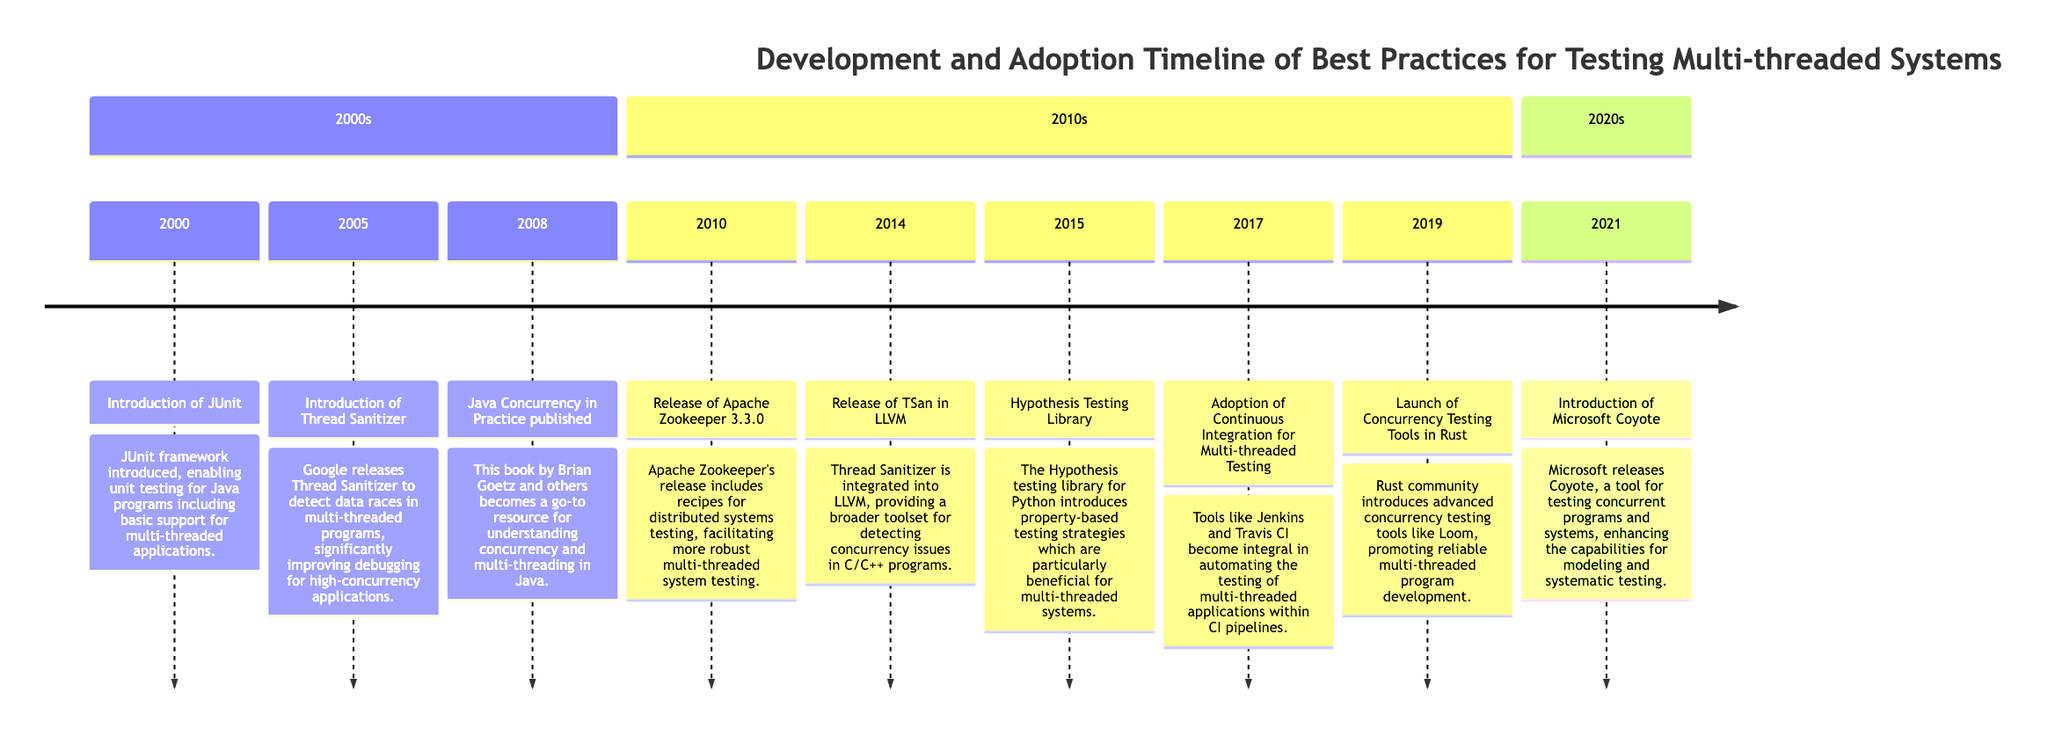What event was introduced in 2000? The timeline indicates that in 2000, the "Introduction of JUnit" was the event. This is explicitly stated in the diagram and marks a significant moment in the development of testing frameworks for multi-threaded systems.
Answer: Introduction of JUnit How many events are listed in the 2010s section? By counting the entries in the "2010s" section of the timeline, there are six notable events listed. This includes different tools and methodologies relevant to multi-threaded testing, with each event clearly defined within that section.
Answer: 6 What was released in 2015? According to the timeline, the "Hypothesis Testing Library" was released in 2015. This is presented as a significant advancement in testing methodologies for multi-threaded systems.
Answer: Hypothesis Testing Library Which tool was integrated into LLVM in 2014? The timeline shows that in 2014, the "Release of TSan in LLVM" was the event. This indicates that Thread Sanitizer became part of the LLVM project, enhancing its concurrency testing capabilities.
Answer: TSan in LLVM What year did Microsoft release Coyote? The timeline details that "Microsoft Coyote" was introduced in 2021. This event is relevant as it marks an important development in tools for systematic testing in concurrent programs.
Answer: 2021 What was the main purpose of introducing Thread Sanitizer in 2005? The timeline states that Thread Sanitizer was released to detect data races in multi-threaded programs, indicating its purpose to enhance debugging in high-concurrency applications.
Answer: Detect data races Which book became a go-to resource in 2008? The timeline indicates that "Java Concurrency in Practice" became a key resource for understanding concurrency in 2008. This event emphasizes the importance of literature in the development of best practices.
Answer: Java Concurrency in Practice What notable shift occurred in 2017 regarding multi-threaded testing? In 2017, the timeline records the "Adoption of Continuous Integration for Multi-threaded Testing" as a significant shift, indicating that automated testing tools became critical within CI pipelines for managing multi-threaded applications.
Answer: Adoption of Continuous Integration for Multi-threaded Testing How many years separate the event of JUnit introduction and the release of Coyote? The timeline shows that JUnit was introduced in 2000 and Coyote was released in 2021, making the difference 21 years between these two significant events in the evolution of testing practices.
Answer: 21 years 